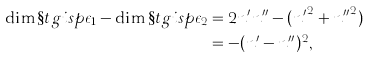<formula> <loc_0><loc_0><loc_500><loc_500>\dim \S t g i s p { \epsilon _ { 1 } } - \dim \S t g i s p { \epsilon _ { 2 } } & = 2 n ^ { \prime } n ^ { \prime \prime } - ( { n ^ { \prime } } ^ { 2 } + { n ^ { \prime \prime } } ^ { 2 } ) \\ & = - ( n ^ { \prime } - n ^ { \prime \prime } ) ^ { 2 } ,</formula> 